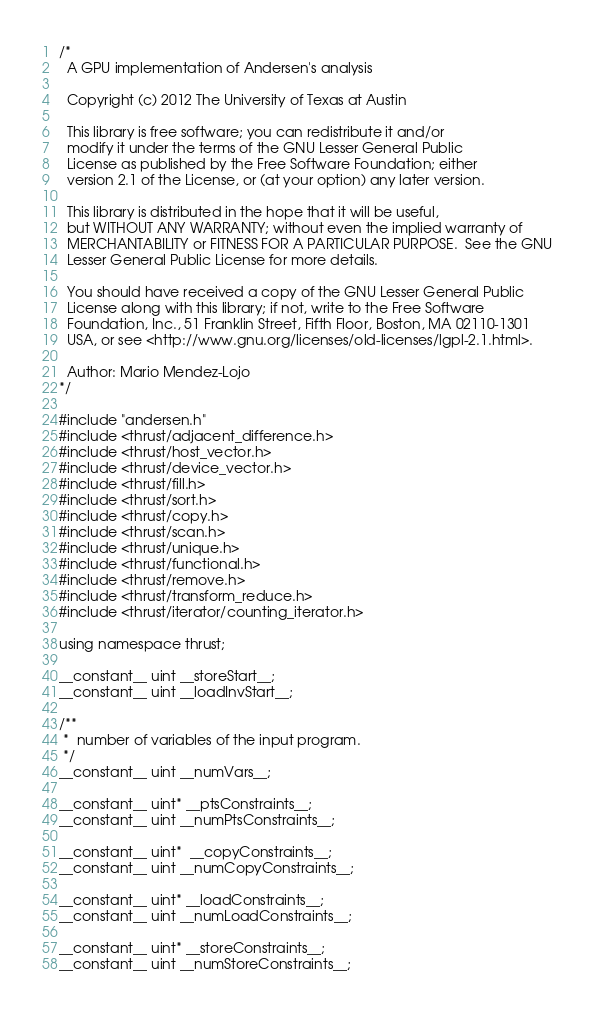<code> <loc_0><loc_0><loc_500><loc_500><_Cuda_>/*
  A GPU implementation of Andersen's analysis

  Copyright (c) 2012 The University of Texas at Austin

  This library is free software; you can redistribute it and/or
  modify it under the terms of the GNU Lesser General Public
  License as published by the Free Software Foundation; either
  version 2.1 of the License, or (at your option) any later version.

  This library is distributed in the hope that it will be useful,
  but WITHOUT ANY WARRANTY; without even the implied warranty of
  MERCHANTABILITY or FITNESS FOR A PARTICULAR PURPOSE.  See the GNU
  Lesser General Public License for more details.

  You should have received a copy of the GNU Lesser General Public
  License along with this library; if not, write to the Free Software
  Foundation, Inc., 51 Franklin Street, Fifth Floor, Boston, MA 02110-1301
  USA, or see <http://www.gnu.org/licenses/old-licenses/lgpl-2.1.html>.

  Author: Mario Mendez-Lojo
*/

#include "andersen.h"
#include <thrust/adjacent_difference.h>
#include <thrust/host_vector.h>
#include <thrust/device_vector.h>
#include <thrust/fill.h>
#include <thrust/sort.h>
#include <thrust/copy.h>
#include <thrust/scan.h>
#include <thrust/unique.h>
#include <thrust/functional.h>
#include <thrust/remove.h>
#include <thrust/transform_reduce.h>
#include <thrust/iterator/counting_iterator.h>

using namespace thrust;

__constant__ uint __storeStart__;
__constant__ uint __loadInvStart__;

/**
 *  number of variables of the input program.
 */
__constant__ uint __numVars__;

__constant__ uint* __ptsConstraints__;
__constant__ uint __numPtsConstraints__;

__constant__ uint*  __copyConstraints__;
__constant__ uint __numCopyConstraints__;

__constant__ uint* __loadConstraints__;
__constant__ uint __numLoadConstraints__;

__constant__ uint* __storeConstraints__;
__constant__ uint __numStoreConstraints__;</code> 